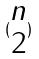<formula> <loc_0><loc_0><loc_500><loc_500>( \begin{matrix} n \\ 2 \end{matrix} )</formula> 